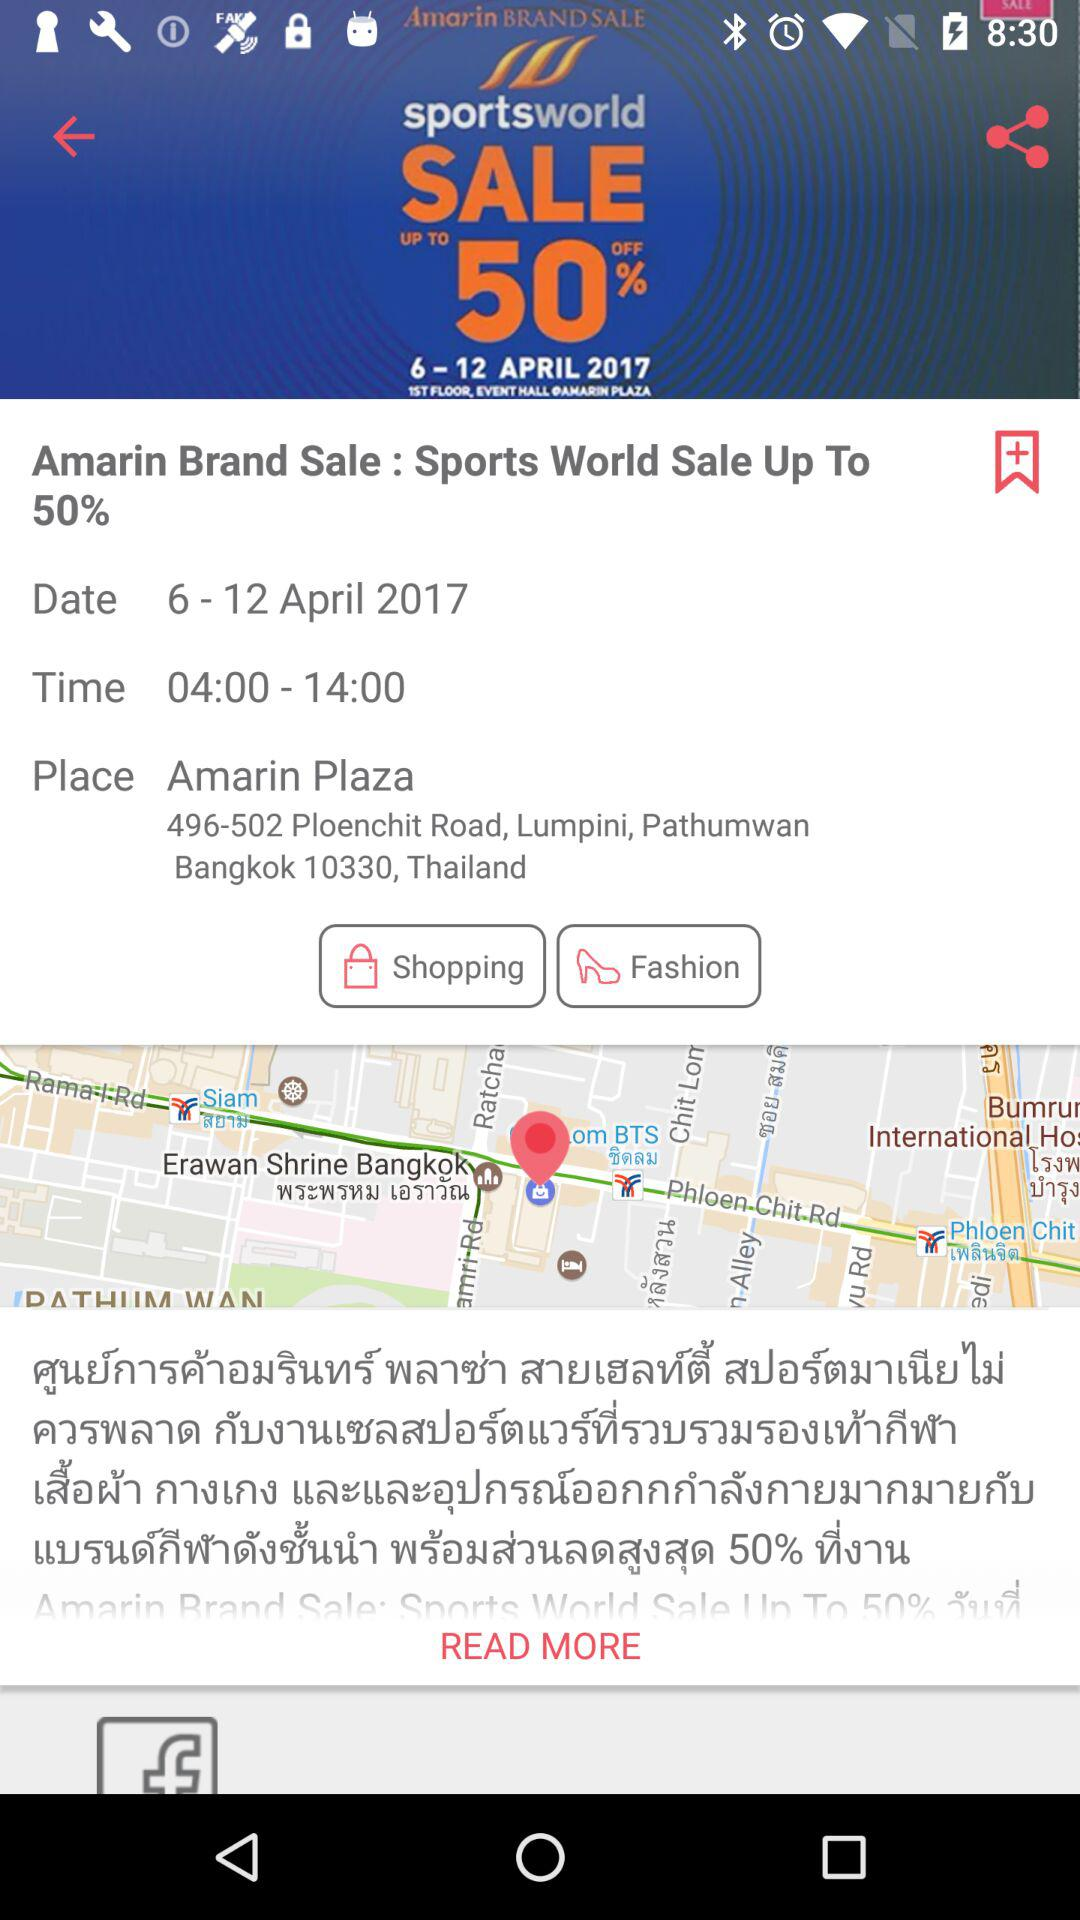What is the name of the brand? The name of the brand is "Amarin". 